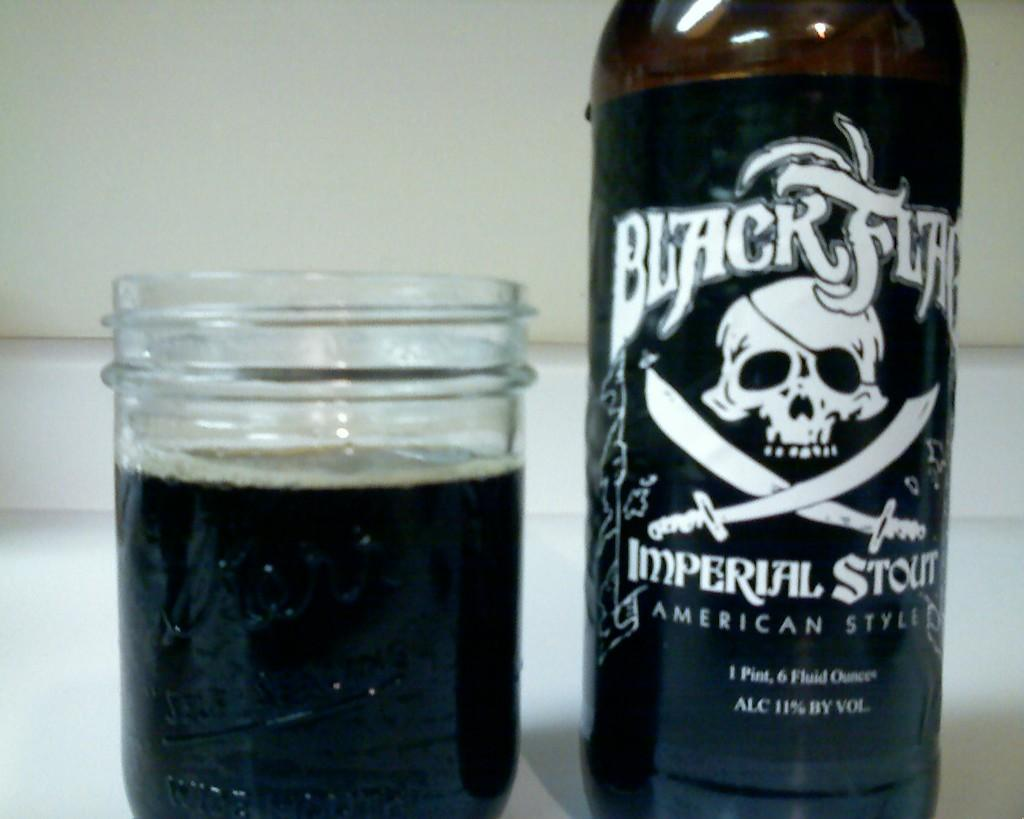<image>
Give a short and clear explanation of the subsequent image. A bottle of Black Flag Imperial Stout next to a glass of beer. 